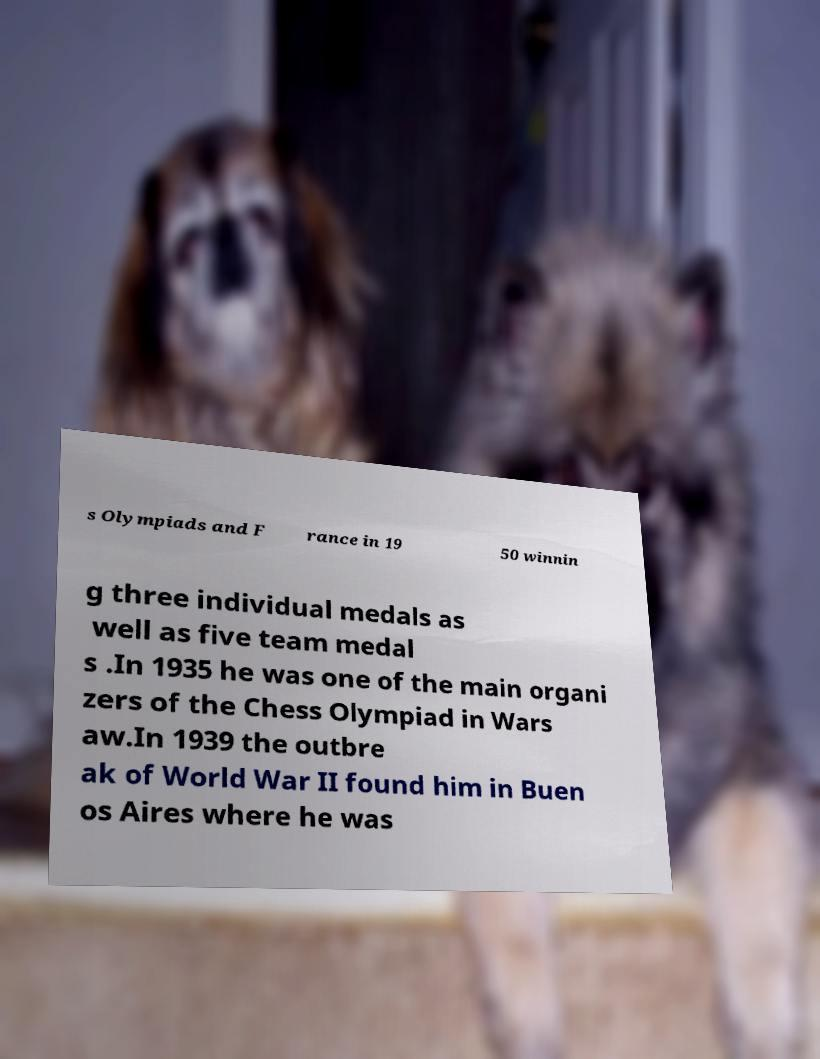Can you read and provide the text displayed in the image?This photo seems to have some interesting text. Can you extract and type it out for me? s Olympiads and F rance in 19 50 winnin g three individual medals as well as five team medal s .In 1935 he was one of the main organi zers of the Chess Olympiad in Wars aw.In 1939 the outbre ak of World War II found him in Buen os Aires where he was 